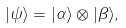<formula> <loc_0><loc_0><loc_500><loc_500>| \psi \rangle = | \alpha \rangle \otimes | \beta \rangle ,</formula> 